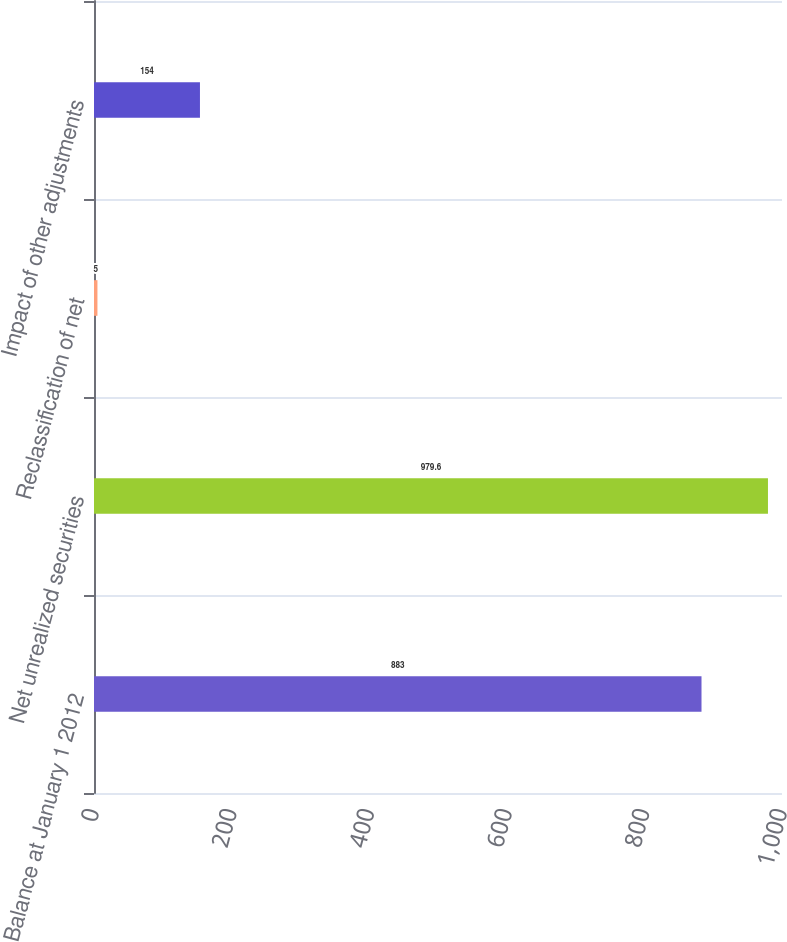Convert chart. <chart><loc_0><loc_0><loc_500><loc_500><bar_chart><fcel>Balance at January 1 2012<fcel>Net unrealized securities<fcel>Reclassification of net<fcel>Impact of other adjustments<nl><fcel>883<fcel>979.6<fcel>5<fcel>154<nl></chart> 